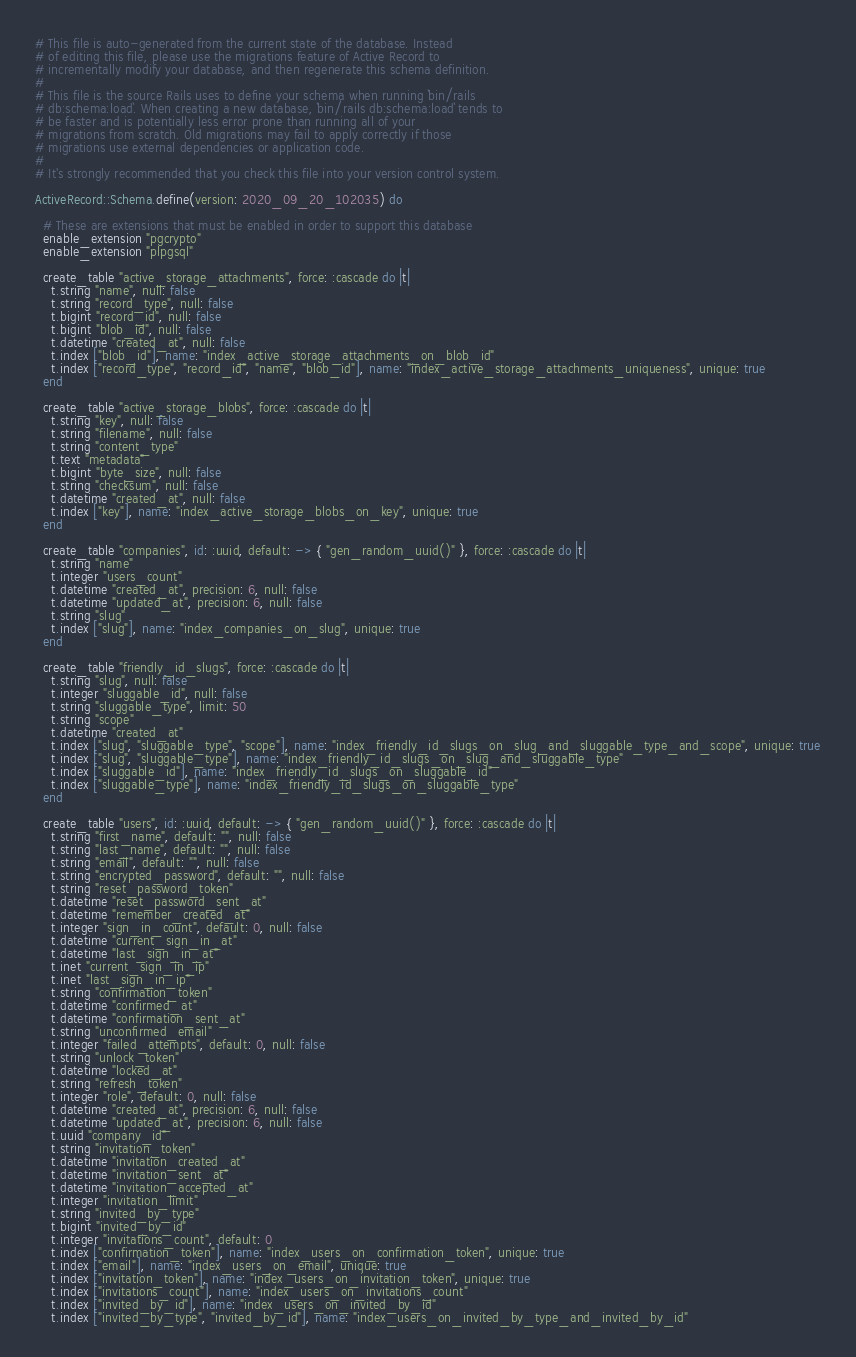<code> <loc_0><loc_0><loc_500><loc_500><_Ruby_># This file is auto-generated from the current state of the database. Instead
# of editing this file, please use the migrations feature of Active Record to
# incrementally modify your database, and then regenerate this schema definition.
#
# This file is the source Rails uses to define your schema when running `bin/rails
# db:schema:load`. When creating a new database, `bin/rails db:schema:load` tends to
# be faster and is potentially less error prone than running all of your
# migrations from scratch. Old migrations may fail to apply correctly if those
# migrations use external dependencies or application code.
#
# It's strongly recommended that you check this file into your version control system.

ActiveRecord::Schema.define(version: 2020_09_20_102035) do

  # These are extensions that must be enabled in order to support this database
  enable_extension "pgcrypto"
  enable_extension "plpgsql"

  create_table "active_storage_attachments", force: :cascade do |t|
    t.string "name", null: false
    t.string "record_type", null: false
    t.bigint "record_id", null: false
    t.bigint "blob_id", null: false
    t.datetime "created_at", null: false
    t.index ["blob_id"], name: "index_active_storage_attachments_on_blob_id"
    t.index ["record_type", "record_id", "name", "blob_id"], name: "index_active_storage_attachments_uniqueness", unique: true
  end

  create_table "active_storage_blobs", force: :cascade do |t|
    t.string "key", null: false
    t.string "filename", null: false
    t.string "content_type"
    t.text "metadata"
    t.bigint "byte_size", null: false
    t.string "checksum", null: false
    t.datetime "created_at", null: false
    t.index ["key"], name: "index_active_storage_blobs_on_key", unique: true
  end

  create_table "companies", id: :uuid, default: -> { "gen_random_uuid()" }, force: :cascade do |t|
    t.string "name"
    t.integer "users_count"
    t.datetime "created_at", precision: 6, null: false
    t.datetime "updated_at", precision: 6, null: false
    t.string "slug"
    t.index ["slug"], name: "index_companies_on_slug", unique: true
  end

  create_table "friendly_id_slugs", force: :cascade do |t|
    t.string "slug", null: false
    t.integer "sluggable_id", null: false
    t.string "sluggable_type", limit: 50
    t.string "scope"
    t.datetime "created_at"
    t.index ["slug", "sluggable_type", "scope"], name: "index_friendly_id_slugs_on_slug_and_sluggable_type_and_scope", unique: true
    t.index ["slug", "sluggable_type"], name: "index_friendly_id_slugs_on_slug_and_sluggable_type"
    t.index ["sluggable_id"], name: "index_friendly_id_slugs_on_sluggable_id"
    t.index ["sluggable_type"], name: "index_friendly_id_slugs_on_sluggable_type"
  end

  create_table "users", id: :uuid, default: -> { "gen_random_uuid()" }, force: :cascade do |t|
    t.string "first_name", default: "", null: false
    t.string "last_name", default: "", null: false
    t.string "email", default: "", null: false
    t.string "encrypted_password", default: "", null: false
    t.string "reset_password_token"
    t.datetime "reset_password_sent_at"
    t.datetime "remember_created_at"
    t.integer "sign_in_count", default: 0, null: false
    t.datetime "current_sign_in_at"
    t.datetime "last_sign_in_at"
    t.inet "current_sign_in_ip"
    t.inet "last_sign_in_ip"
    t.string "confirmation_token"
    t.datetime "confirmed_at"
    t.datetime "confirmation_sent_at"
    t.string "unconfirmed_email"
    t.integer "failed_attempts", default: 0, null: false
    t.string "unlock_token"
    t.datetime "locked_at"
    t.string "refresh_token"
    t.integer "role", default: 0, null: false
    t.datetime "created_at", precision: 6, null: false
    t.datetime "updated_at", precision: 6, null: false
    t.uuid "company_id"
    t.string "invitation_token"
    t.datetime "invitation_created_at"
    t.datetime "invitation_sent_at"
    t.datetime "invitation_accepted_at"
    t.integer "invitation_limit"
    t.string "invited_by_type"
    t.bigint "invited_by_id"
    t.integer "invitations_count", default: 0
    t.index ["confirmation_token"], name: "index_users_on_confirmation_token", unique: true
    t.index ["email"], name: "index_users_on_email", unique: true
    t.index ["invitation_token"], name: "index_users_on_invitation_token", unique: true
    t.index ["invitations_count"], name: "index_users_on_invitations_count"
    t.index ["invited_by_id"], name: "index_users_on_invited_by_id"
    t.index ["invited_by_type", "invited_by_id"], name: "index_users_on_invited_by_type_and_invited_by_id"</code> 